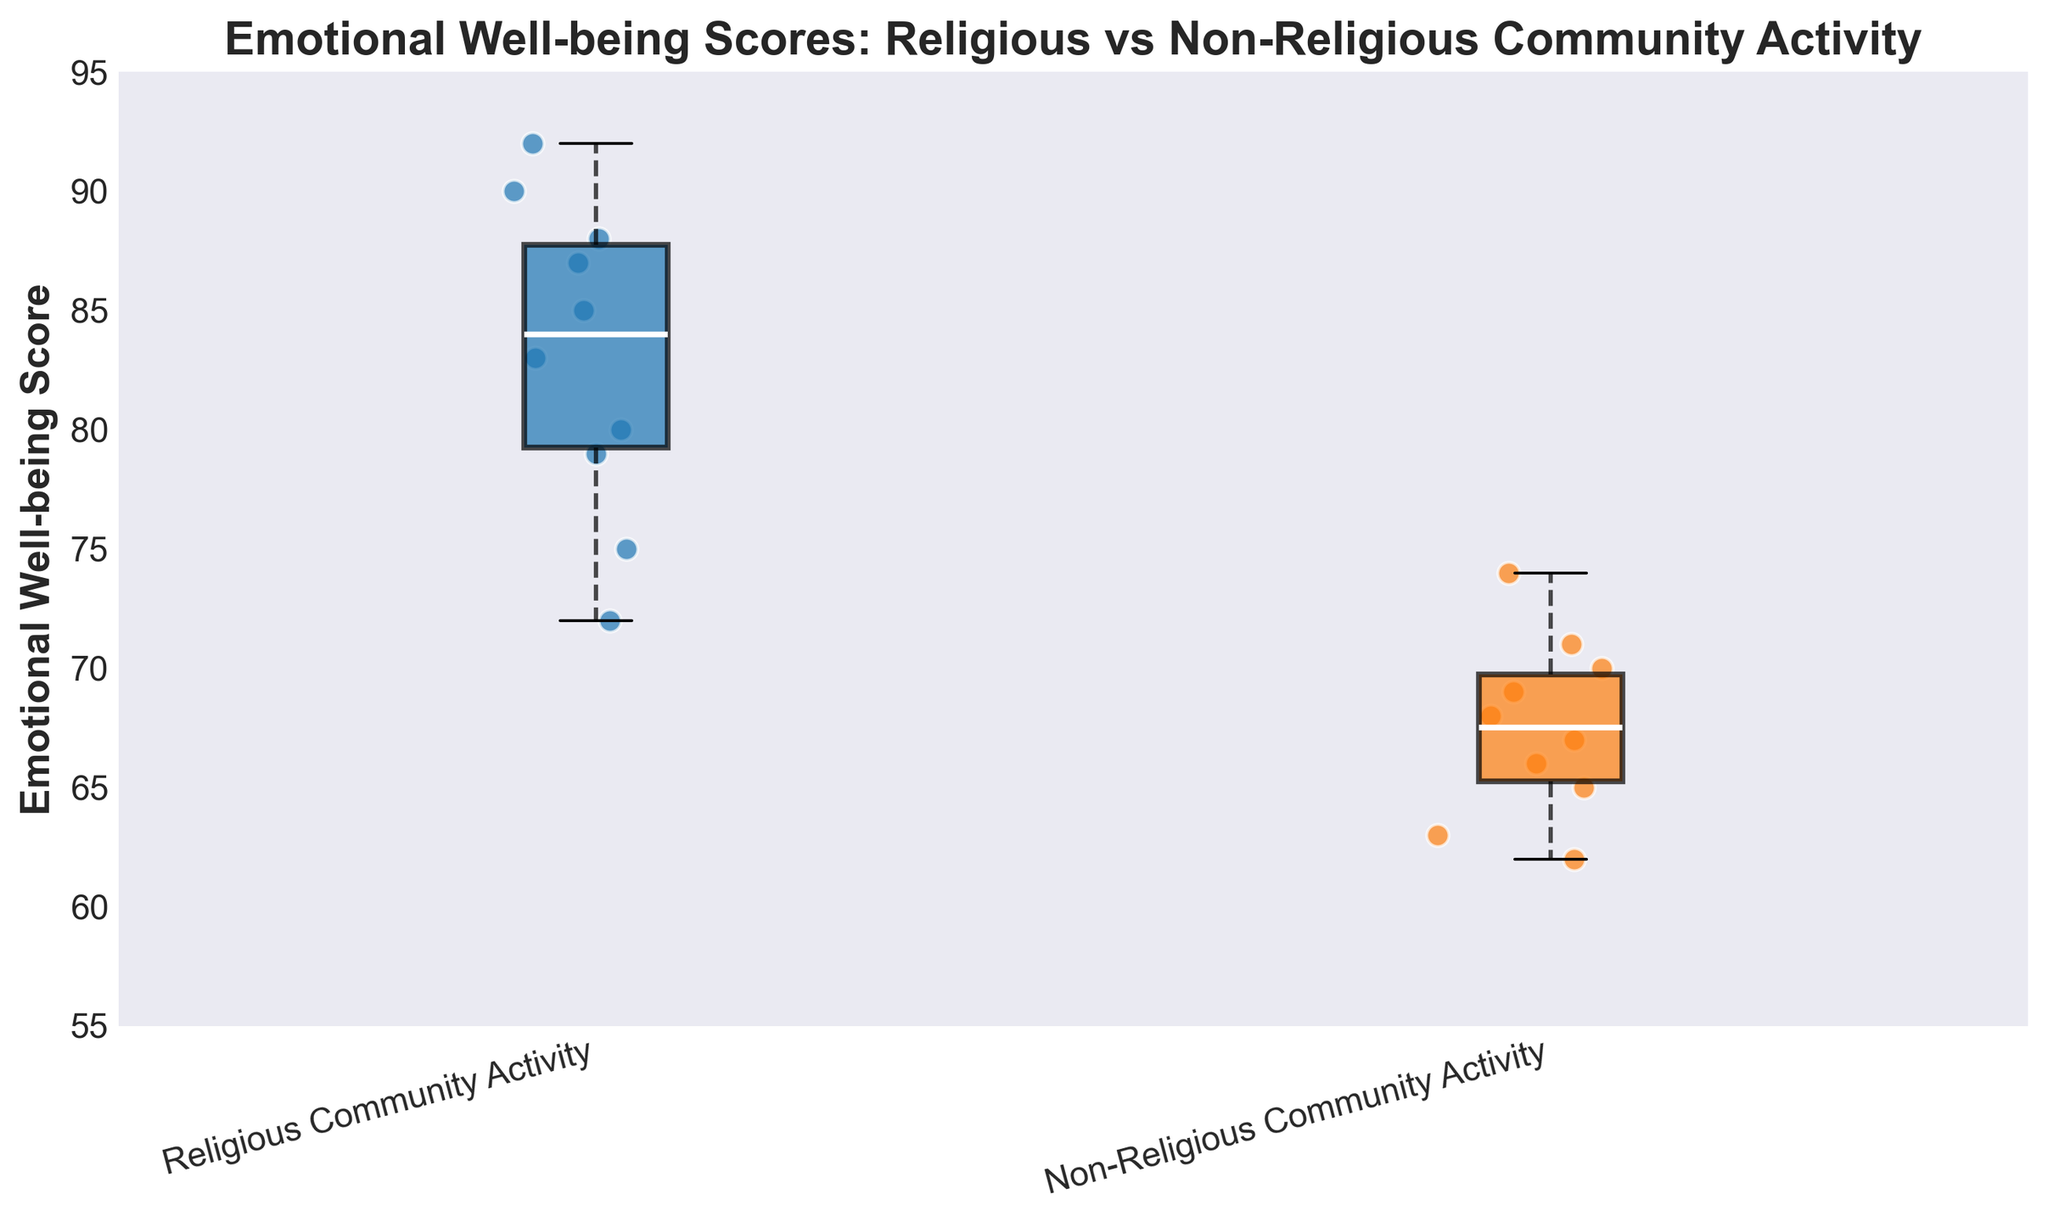What is the title of the plot? The title of the plot is typically displayed at the top of the figure to provide a description of what the plot shows. In this figure, the title is clearly placed to detail the comparison between two groups with the focus on emotional well-being scores.
Answer: Emotional Well-being Scores: Religious vs Non-Religious Community Activity What are the labels on the x-axis? The x-axis labels indicate the categories being compared in the plot. This tells us which groups the emotional well-being scores belong to.
Answer: Religious Community Activity, Non-Religious Community Activity Which group has the higher median emotional well-being score? To find the median emotional well-being score for each group, we look at the middle line inside each box on the box plot. The group with the higher line would be the one with the higher median score.
Answer: Religious Community Activity How many participants were in the Religious Community Activity group? To determine the number of participants, we count the number of scatter points in the Religious Community Activity group. Each scatter point represents one individual.
Answer: 10 What is the range of emotional well-being scores for the Non-Religious Community Activity group? The range is found by subtracting the smallest value (the bottom whisker of the box plot) from the largest value (the top whisker of the box plot) for the Non-Religious Community Activity group.
Answer: 62 - 74 Comparing the interquartile ranges (IQRs) of the two groups, which one has a larger IQR? The interquartile range (IQR) is the length of the box in the box plot. We compare the lengths to determine which group has a larger IQR.
Answer: Religious Community Activity What is the highest emotional well-being score in the Religious Community Activity group? The highest score in a box plot can be found at the top whisker or the highest data point. For the Religious Community Activity group, we look for the highest point in this area.
Answer: 92 What is the minimum emotional well-being score in the Non-Religious Community Activity group? The minimum score is the lowest point at the bottom whisker or the lowest data point in the Non-Religious Community Activity group.
Answer: 62 Which group shows more variability in emotional well-being scores? Variability can be inferred by looking at the spread of the scores in the box plot, including the whiskers and scatter points. A larger spread indicates more variability.
Answer: Religious Community Activity What color represents the Religious Community Activity group in the plot? The color representing a group is shown by the color of the box and scatter points corresponding to that group in the figure. For Religious Community Activity, we identify this from the color coding.
Answer: Blue 